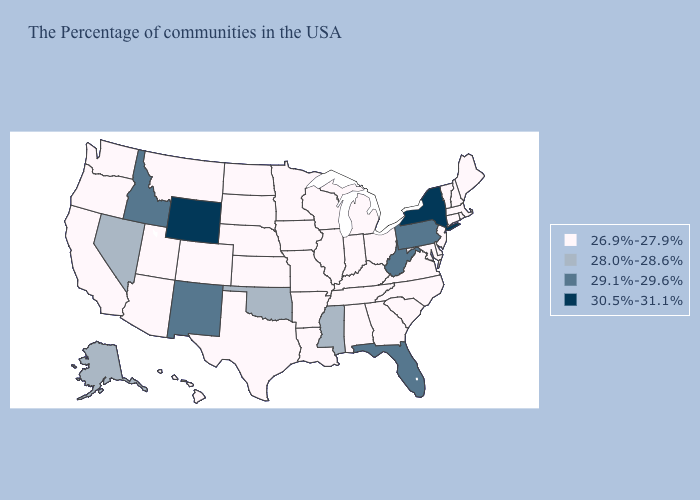What is the lowest value in the West?
Short answer required. 26.9%-27.9%. Does North Dakota have the highest value in the USA?
Keep it brief. No. Is the legend a continuous bar?
Give a very brief answer. No. What is the highest value in states that border Texas?
Quick response, please. 29.1%-29.6%. Does Virginia have a lower value than Kansas?
Quick response, please. No. Among the states that border Arkansas , which have the highest value?
Quick response, please. Mississippi, Oklahoma. What is the value of Ohio?
Keep it brief. 26.9%-27.9%. How many symbols are there in the legend?
Concise answer only. 4. Among the states that border Alabama , does Florida have the highest value?
Answer briefly. Yes. Does Kentucky have the same value as Wyoming?
Be succinct. No. What is the highest value in states that border Connecticut?
Short answer required. 30.5%-31.1%. How many symbols are there in the legend?
Give a very brief answer. 4. Name the states that have a value in the range 30.5%-31.1%?
Quick response, please. New York, Wyoming. What is the highest value in the West ?
Quick response, please. 30.5%-31.1%. 